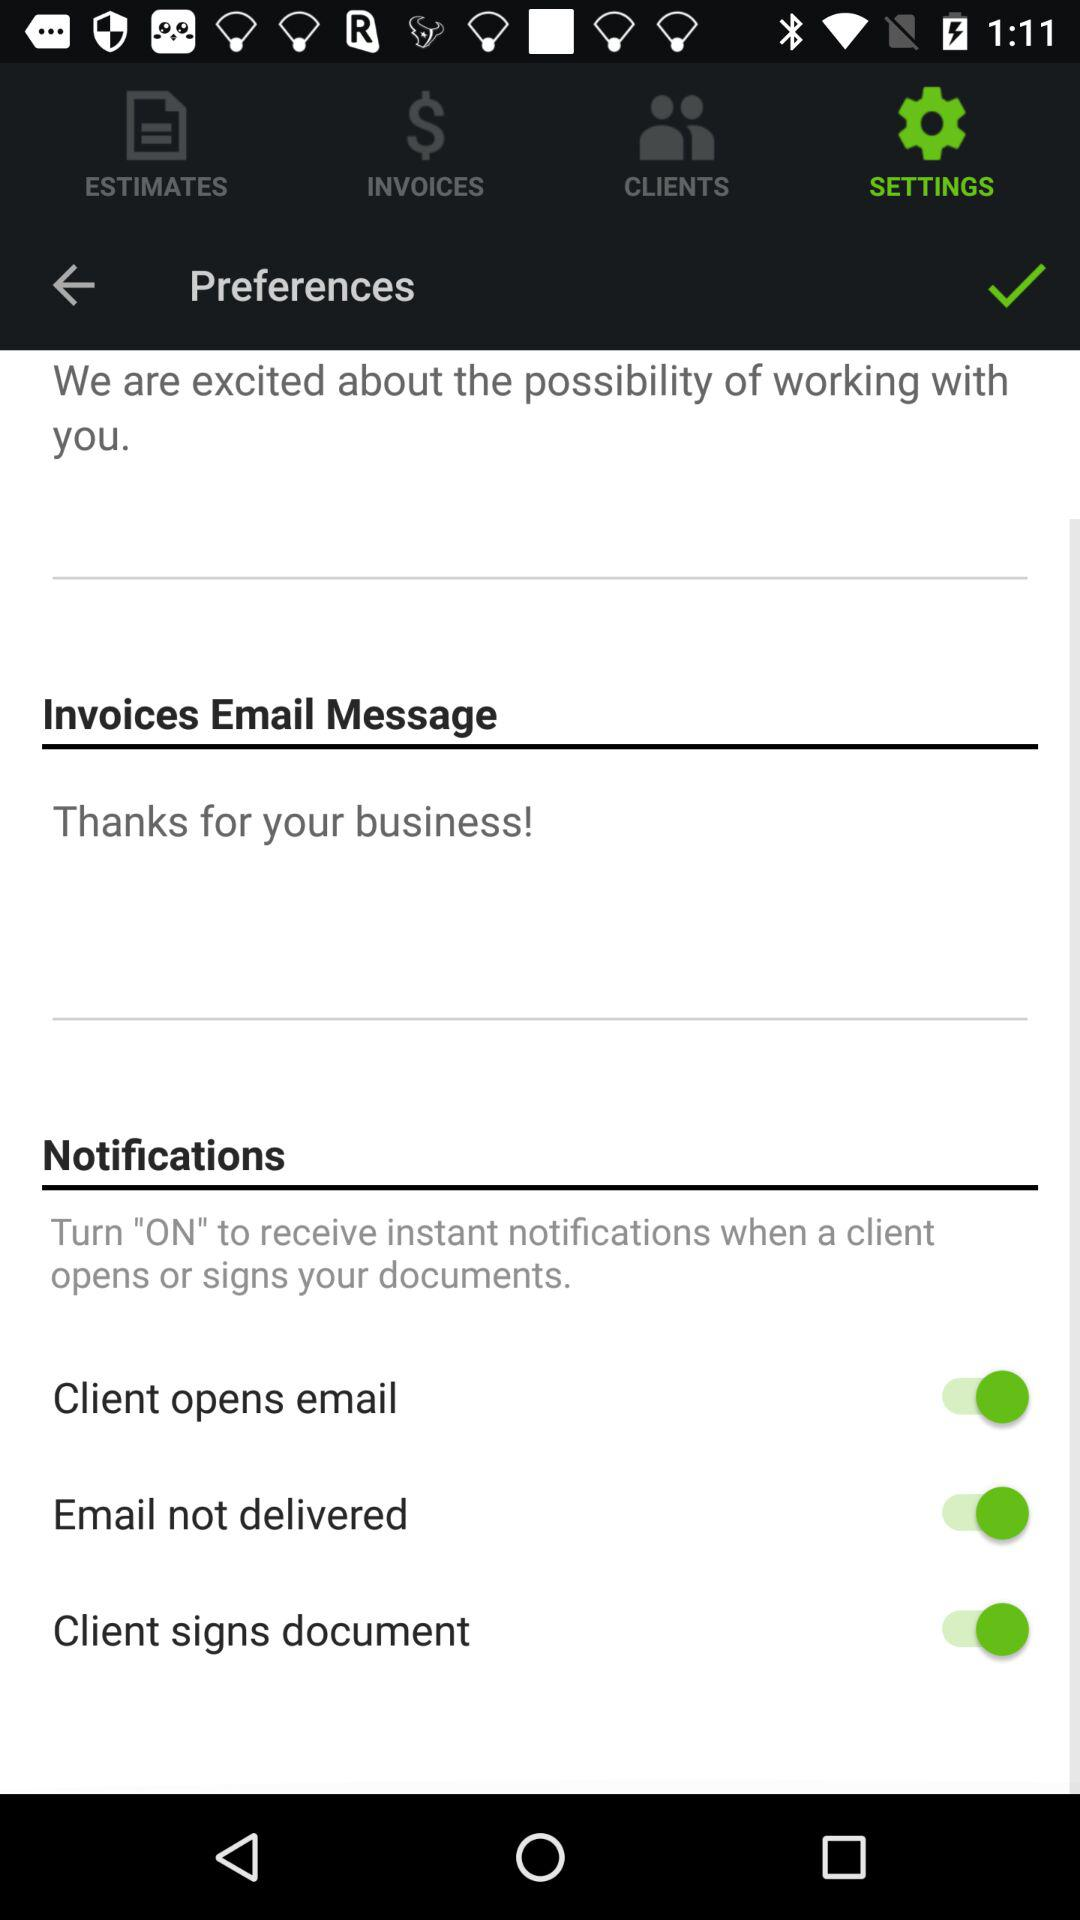Which option is selected? The selected option is "SETTINGS". 